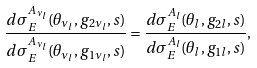Convert formula to latex. <formula><loc_0><loc_0><loc_500><loc_500>\frac { d \sigma _ { E } ^ { A _ { \nu _ { l } } } ( \theta _ { \nu _ { l } } , g _ { 2 \nu _ { l } } , s ) } { d \sigma _ { E } ^ { A _ { \nu _ { l } } } ( \theta _ { \nu _ { l } } , g _ { 1 \nu _ { l } } , s ) } = \frac { d \sigma _ { E } ^ { A _ { l } } ( \theta _ { l } , g _ { 2 l } , s ) } { d \sigma _ { E } ^ { A _ { l } } ( \theta _ { l } , g _ { 1 l } , s ) } ,</formula> 